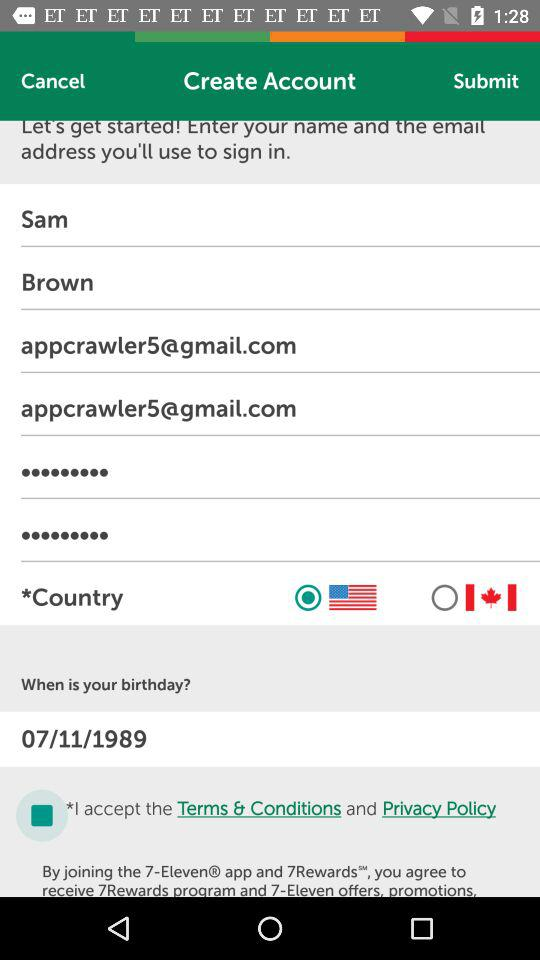What is the user's password?
When the provided information is insufficient, respond with <no answer>. <no answer> 